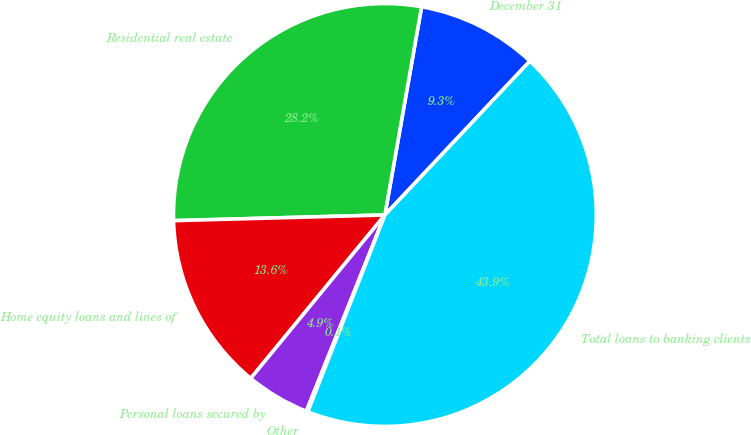<chart> <loc_0><loc_0><loc_500><loc_500><pie_chart><fcel>December 31<fcel>Residential real estate<fcel>Home equity loans and lines of<fcel>Personal loans secured by<fcel>Other<fcel>Total loans to banking clients<nl><fcel>9.25%<fcel>28.2%<fcel>13.63%<fcel>4.88%<fcel>0.12%<fcel>43.91%<nl></chart> 